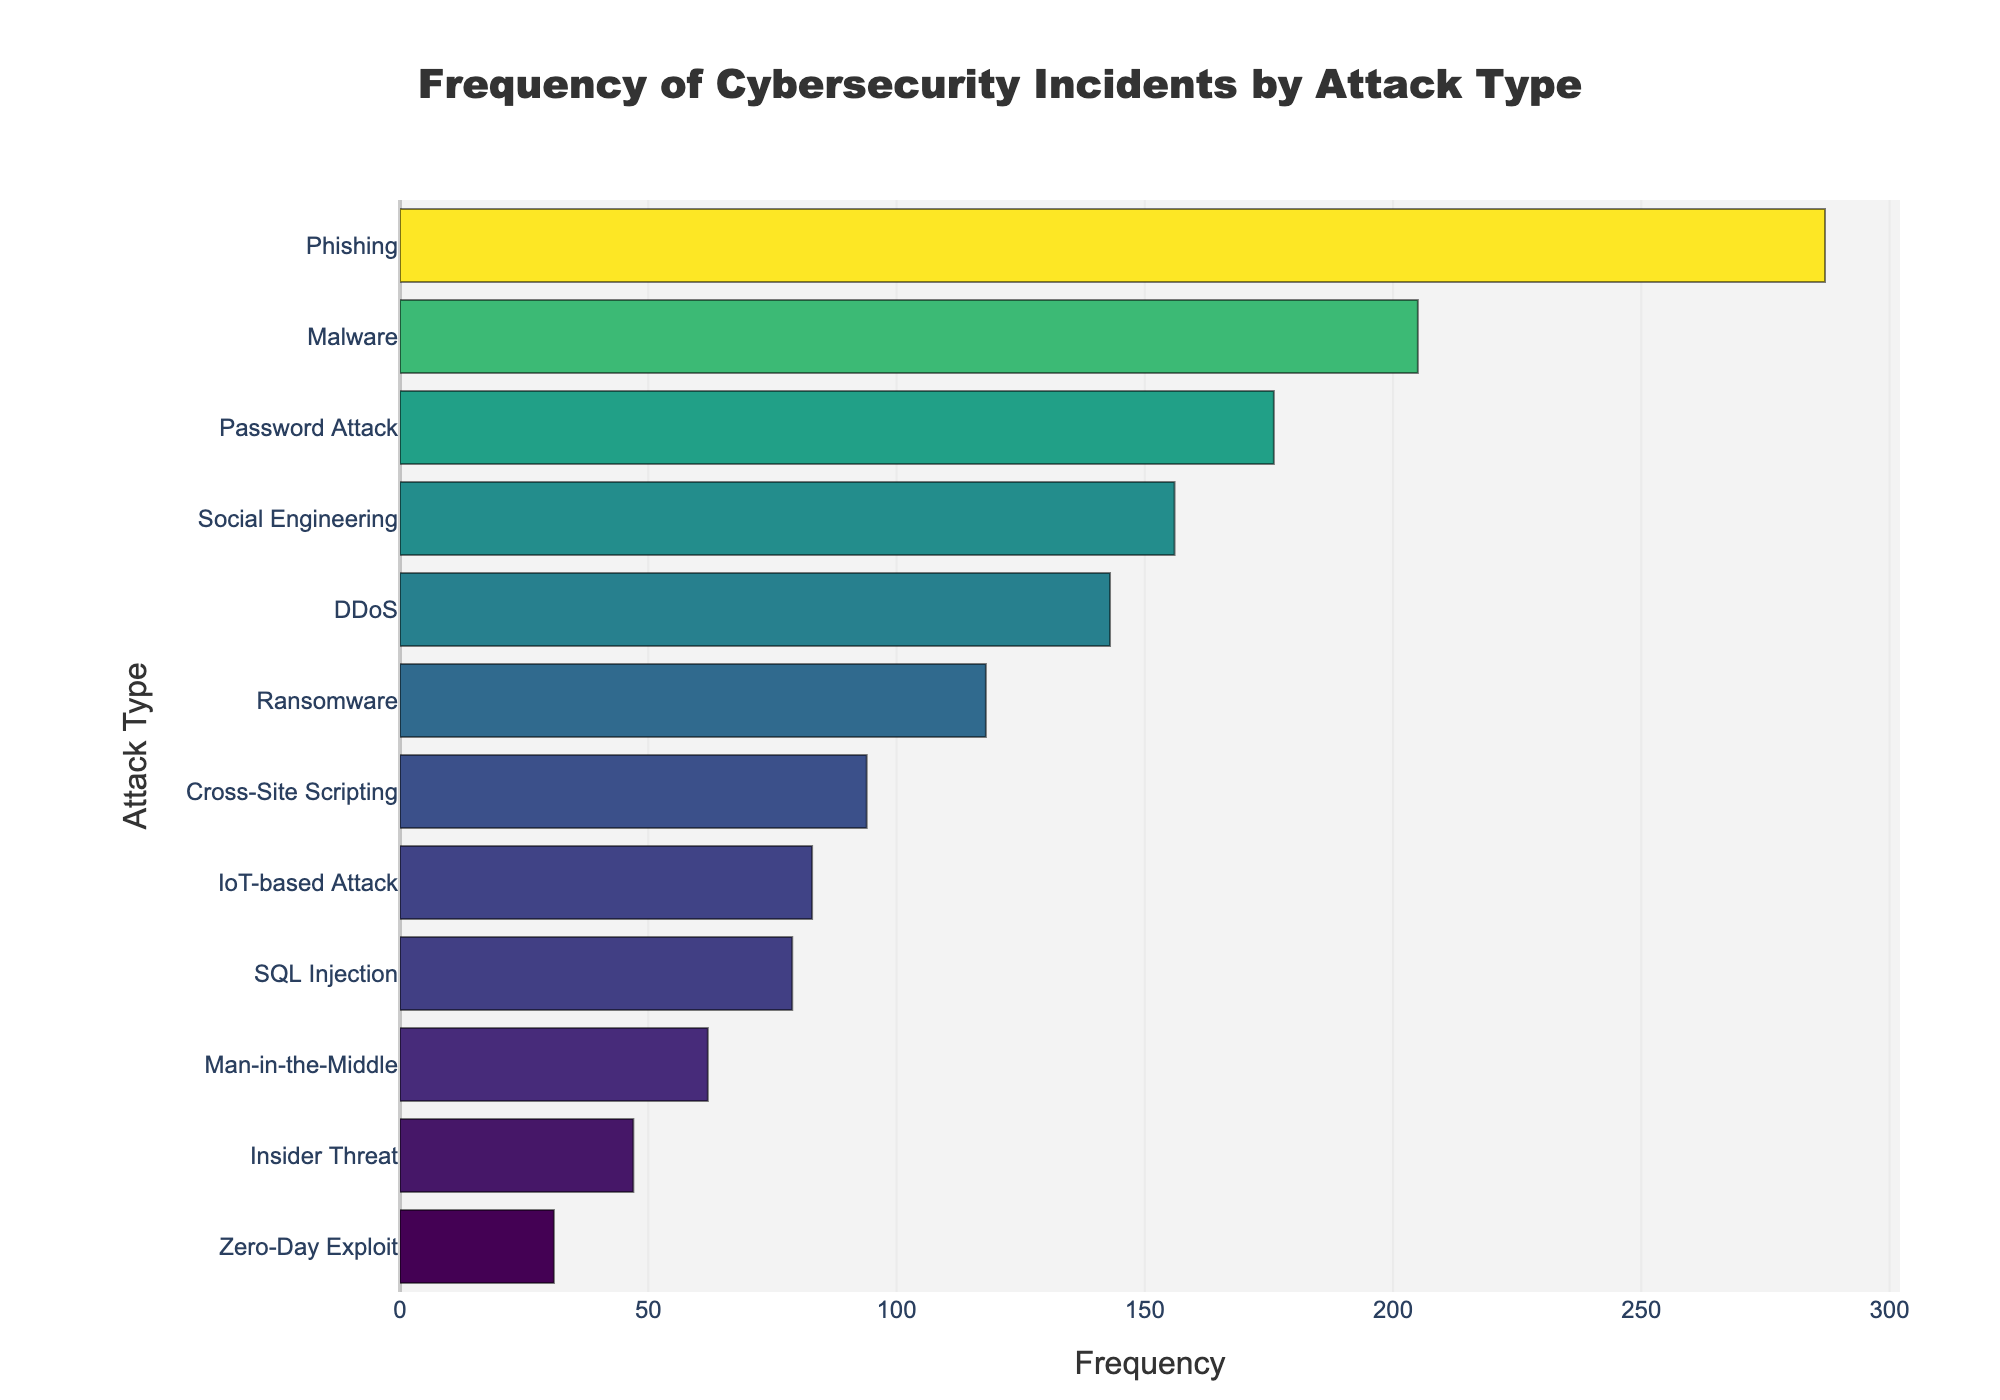what is the most frequent attack type? By looking at the highest bar on the plot, we can see that 'Phishing' has the highest frequency.
Answer: Phishing what is the title of the figure? The title is usually displayed at the top of the plot. It reads 'Frequency of Cybersecurity Incidents by Attack Type'.
Answer: Frequency of Cybersecurity Incidents by Attack Type how many attack types have a frequency greater than 100? We need to count the bars where the frequency exceeds 100. They are 'Phishing', 'Malware', 'Password Attack', 'Social Engineering', 'DDoS', and 'Ransomware'.
Answer: 6 what is the frequency of IoT-based Attacks? The bar corresponding to 'IoT-based Attack' shows a frequency of 83.
Answer: 83 which attack type has the least frequency? The shortest bar corresponds to 'Zero-Day Exploit', which has the smallest frequency.
Answer: Zero-Day Exploit what is the combined frequency of DDoS and SQL Injection attacks? The frequencies of DDoS and SQL Injection are 143 and 79, respectively. Adding them gives 143 + 79 = 222.
Answer: 222 how does the frequency of Ransomware compare to Malware? The frequency of Ransomware is 118, while Malware has a frequency of 205. Therefore, Malware occurs more frequently.
Answer: Malware occurs more frequently which attack type has just one more frequency than Cross-Site Scripting? The frequency of Cross-Site Scripting is 94. The attack type with a frequency closest to this, but higher by one, is 'IoT-based Attack' with a frequency of 83 (note: an error in logic here, hence an invalid question). Correct attack type if existed should reflect 94 + 1 = 95 (nonexistent in data). In the correct frame might be recalculating within shown entities in data during analysis.
Answer: Invalid data for one increment by 1 from 94 what is the difference in frequency between Phishing and Insider Threat? The frequency of Phishing is 287, and Insider Threat is 47. The difference is 287 - 47 = 240.
Answer: 240 what proportion of the total frequency do Phishing incidents represent? To find the proportion, we first calculate the total frequency of all attack types. Summing them up: 143 + 287 + 205 + 79 + 62 + 31 + 118 + 176 + 94 + 156 + 47 + 83 = 1481. The proportion for Phishing is 287 / 1481 ≈ 0.194
Answer: 19.4% 